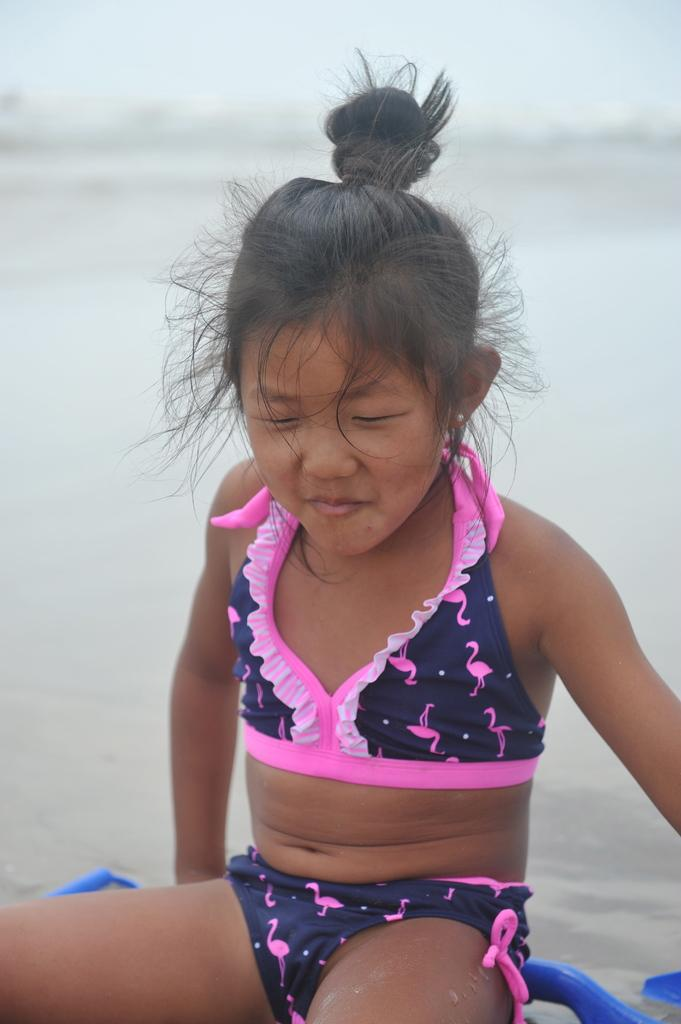Who is present in the image? There is a girl in the image. What natural body of water is visible in the image? There is an ocean visible in the image. What type of music is the girl playing in the image? There is no indication in the image that the girl is playing any music, so it cannot be determined from the picture. 